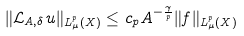Convert formula to latex. <formula><loc_0><loc_0><loc_500><loc_500>\| \mathcal { L } _ { A , \delta } u \| _ { L ^ { p } _ { \mu } ( X ) } \leq c _ { p } A ^ { - \frac { \gamma } { p } } \| f \| _ { L ^ { p } _ { \mu } ( X ) }</formula> 